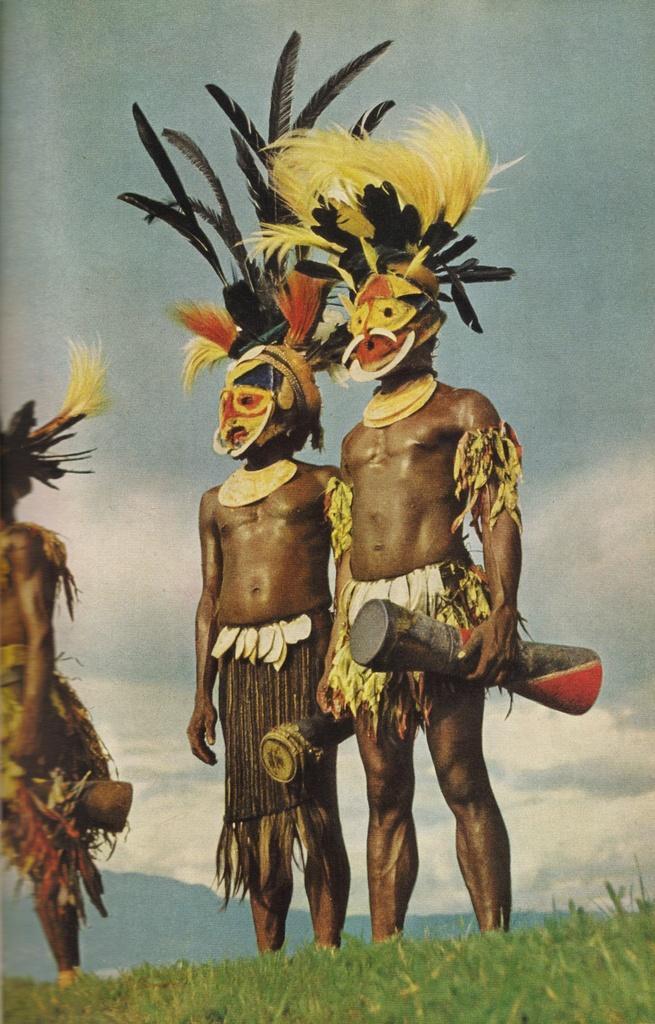Describe this image in one or two sentences. In this picture we can see three persons are standing and holding something, at the bottom there is grass, we can see the sky and clouds in the background. 